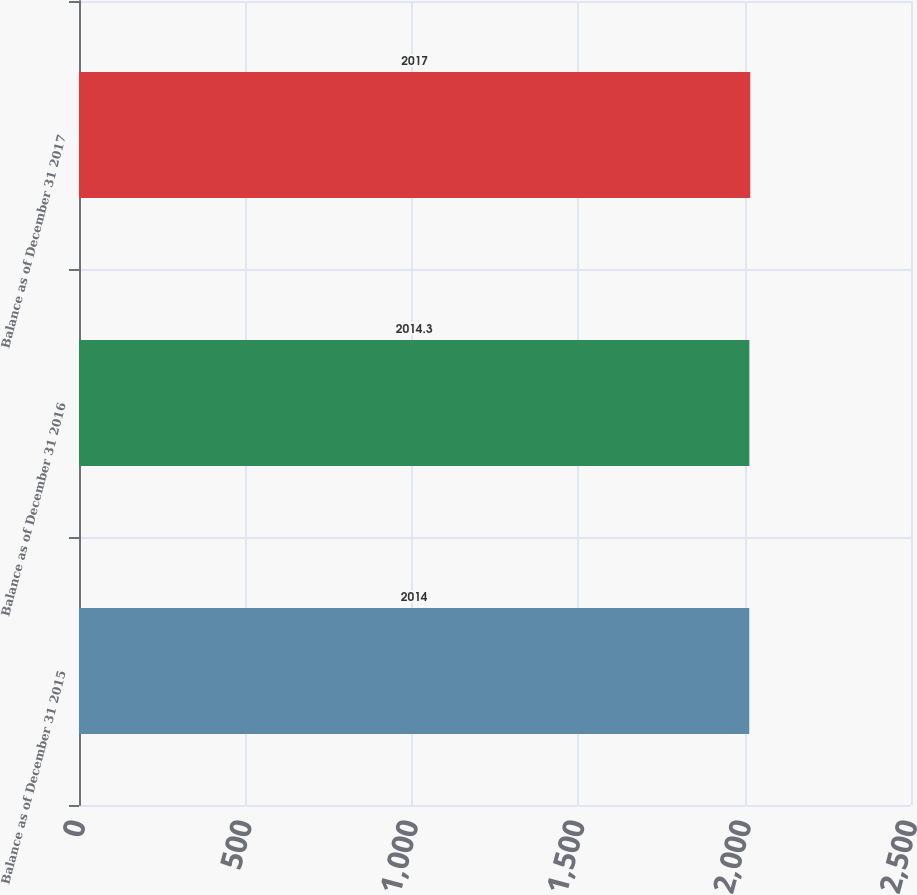Convert chart to OTSL. <chart><loc_0><loc_0><loc_500><loc_500><bar_chart><fcel>Balance as of December 31 2015<fcel>Balance as of December 31 2016<fcel>Balance as of December 31 2017<nl><fcel>2014<fcel>2014.3<fcel>2017<nl></chart> 